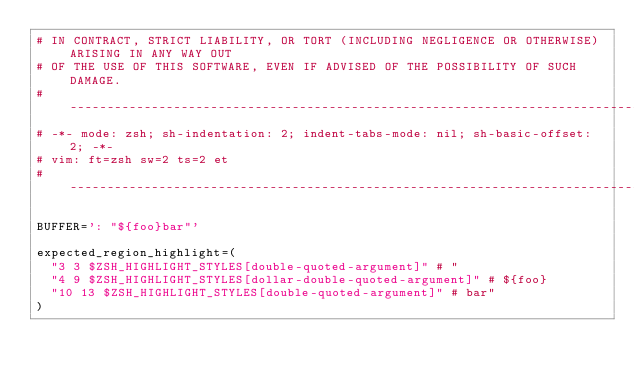Convert code to text. <code><loc_0><loc_0><loc_500><loc_500><_Bash_># IN CONTRACT, STRICT LIABILITY, OR TORT (INCLUDING NEGLIGENCE OR OTHERWISE) ARISING IN ANY WAY OUT
# OF THE USE OF THIS SOFTWARE, EVEN IF ADVISED OF THE POSSIBILITY OF SUCH DAMAGE.
# -------------------------------------------------------------------------------------------------
# -*- mode: zsh; sh-indentation: 2; indent-tabs-mode: nil; sh-basic-offset: 2; -*-
# vim: ft=zsh sw=2 ts=2 et
# -------------------------------------------------------------------------------------------------

BUFFER=': "${foo}bar"'

expected_region_highlight=(
  "3 3 $ZSH_HIGHLIGHT_STYLES[double-quoted-argument]" # "
  "4 9 $ZSH_HIGHLIGHT_STYLES[dollar-double-quoted-argument]" # ${foo}
  "10 13 $ZSH_HIGHLIGHT_STYLES[double-quoted-argument]" # bar"
)
</code> 